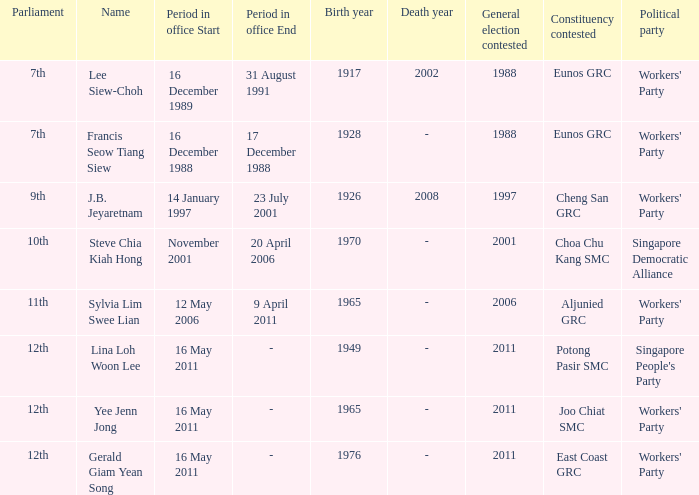In which parliament is lina loh woon lee a member? 12th. 